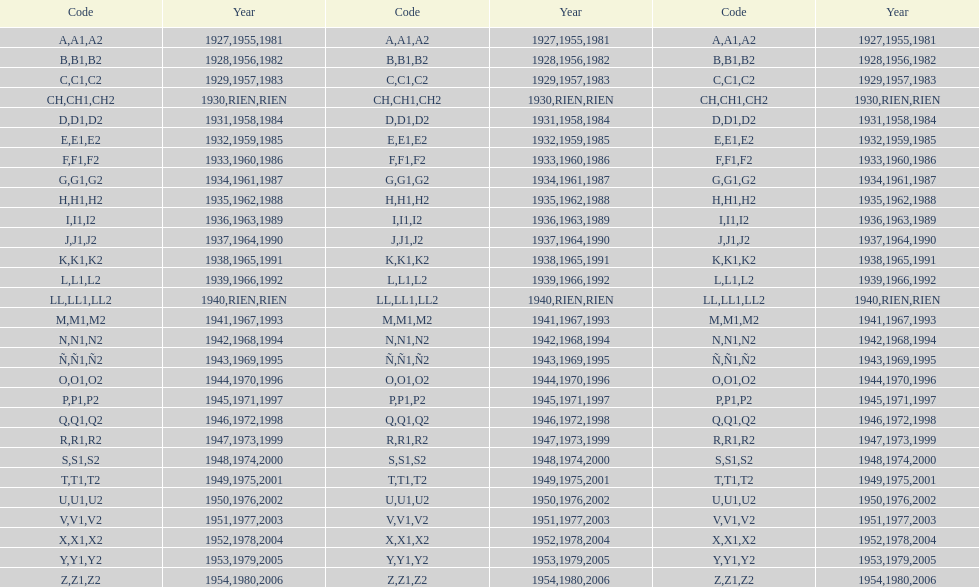Is the e-code below 1950? Yes. 